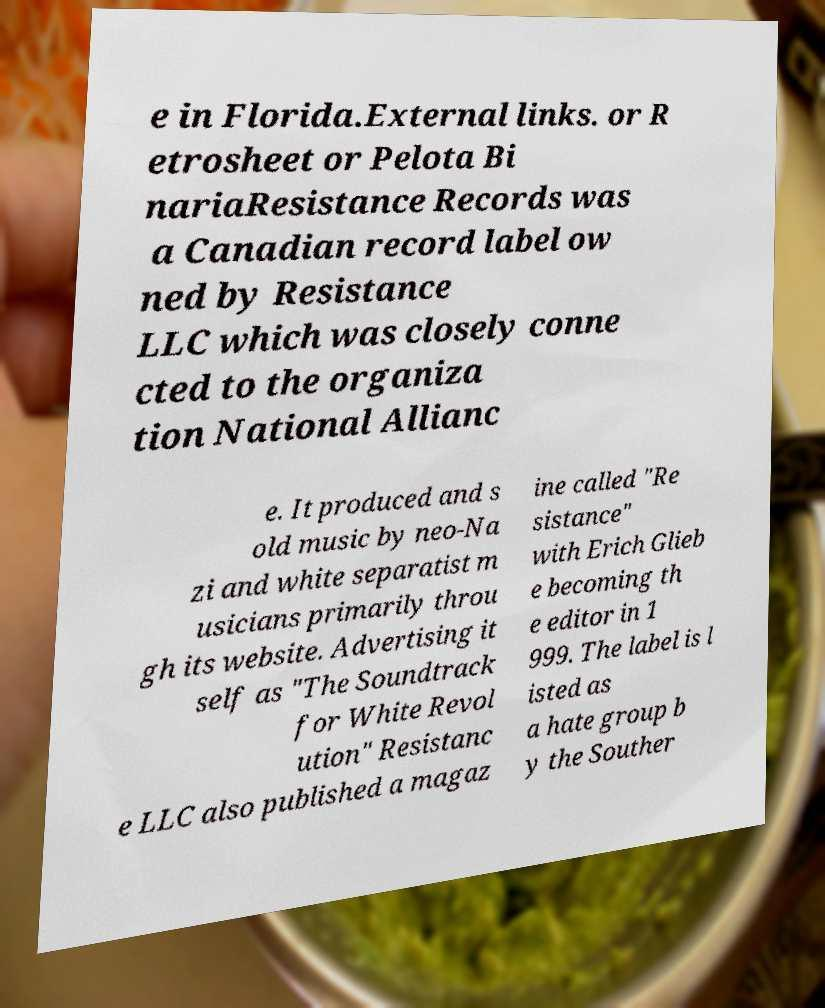Please read and relay the text visible in this image. What does it say? e in Florida.External links. or R etrosheet or Pelota Bi nariaResistance Records was a Canadian record label ow ned by Resistance LLC which was closely conne cted to the organiza tion National Allianc e. It produced and s old music by neo-Na zi and white separatist m usicians primarily throu gh its website. Advertising it self as "The Soundtrack for White Revol ution" Resistanc e LLC also published a magaz ine called "Re sistance" with Erich Glieb e becoming th e editor in 1 999. The label is l isted as a hate group b y the Souther 